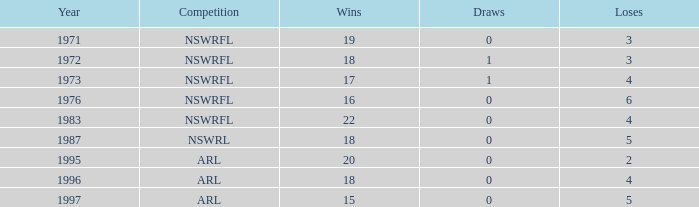What mean victories has 2 defeats, and stalemates fewer than 0? None. 